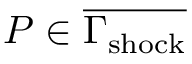<formula> <loc_0><loc_0><loc_500><loc_500>P \in \overline { { \Gamma _ { s h o c k } } }</formula> 